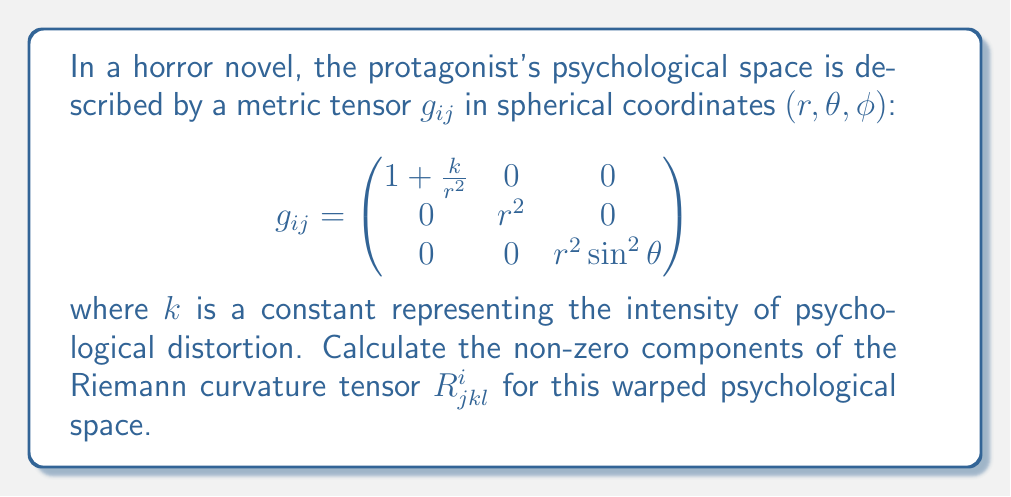Can you answer this question? To calculate the Riemann curvature tensor, we'll follow these steps:

1) First, we need to calculate the Christoffel symbols $\Gamma^i_{jk}$ using the formula:

   $$\Gamma^i_{jk} = \frac{1}{2}g^{im}(\partial_j g_{km} + \partial_k g_{jm} - \partial_m g_{jk})$$

2) The non-zero Christoffel symbols are:

   $$\Gamma^r_{\theta\theta} = -r(1 + \frac{k}{r^2})$$
   $$\Gamma^r_{\phi\phi} = -r(1 + \frac{k}{r^2})\sin^2\theta$$
   $$\Gamma^\theta_{r\theta} = \Gamma^\phi_{r\phi} = \frac{1}{r}$$
   $$\Gamma^\theta_{\phi\phi} = -\sin\theta\cos\theta$$
   $$\Gamma^\phi_{\theta\phi} = \cot\theta$$

3) Now, we can calculate the Riemann curvature tensor using:

   $$R^i_{jkl} = \partial_k \Gamma^i_{jl} - \partial_l \Gamma^i_{jk} + \Gamma^m_{jl}\Gamma^i_{mk} - \Gamma^m_{jk}\Gamma^i_{ml}$$

4) The non-zero components are:

   $$R^r_{\theta r \theta} = -\frac{k}{r^4}$$
   $$R^r_{\phi r \phi} = -\frac{k}{r^4}\sin^2\theta$$
   $$R^\theta_{\phi \theta \phi} = \frac{k}{r^4}\sin^2\theta$$

5) All other components are either zero or can be derived from these by symmetry or antisymmetry properties of the Riemann tensor.
Answer: $R^r_{\theta r \theta} = -\frac{k}{r^4}$, $R^r_{\phi r \phi} = -\frac{k}{r^4}\sin^2\theta$, $R^\theta_{\phi \theta \phi} = \frac{k}{r^4}\sin^2\theta$ 